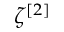<formula> <loc_0><loc_0><loc_500><loc_500>\zeta ^ { [ 2 ] }</formula> 